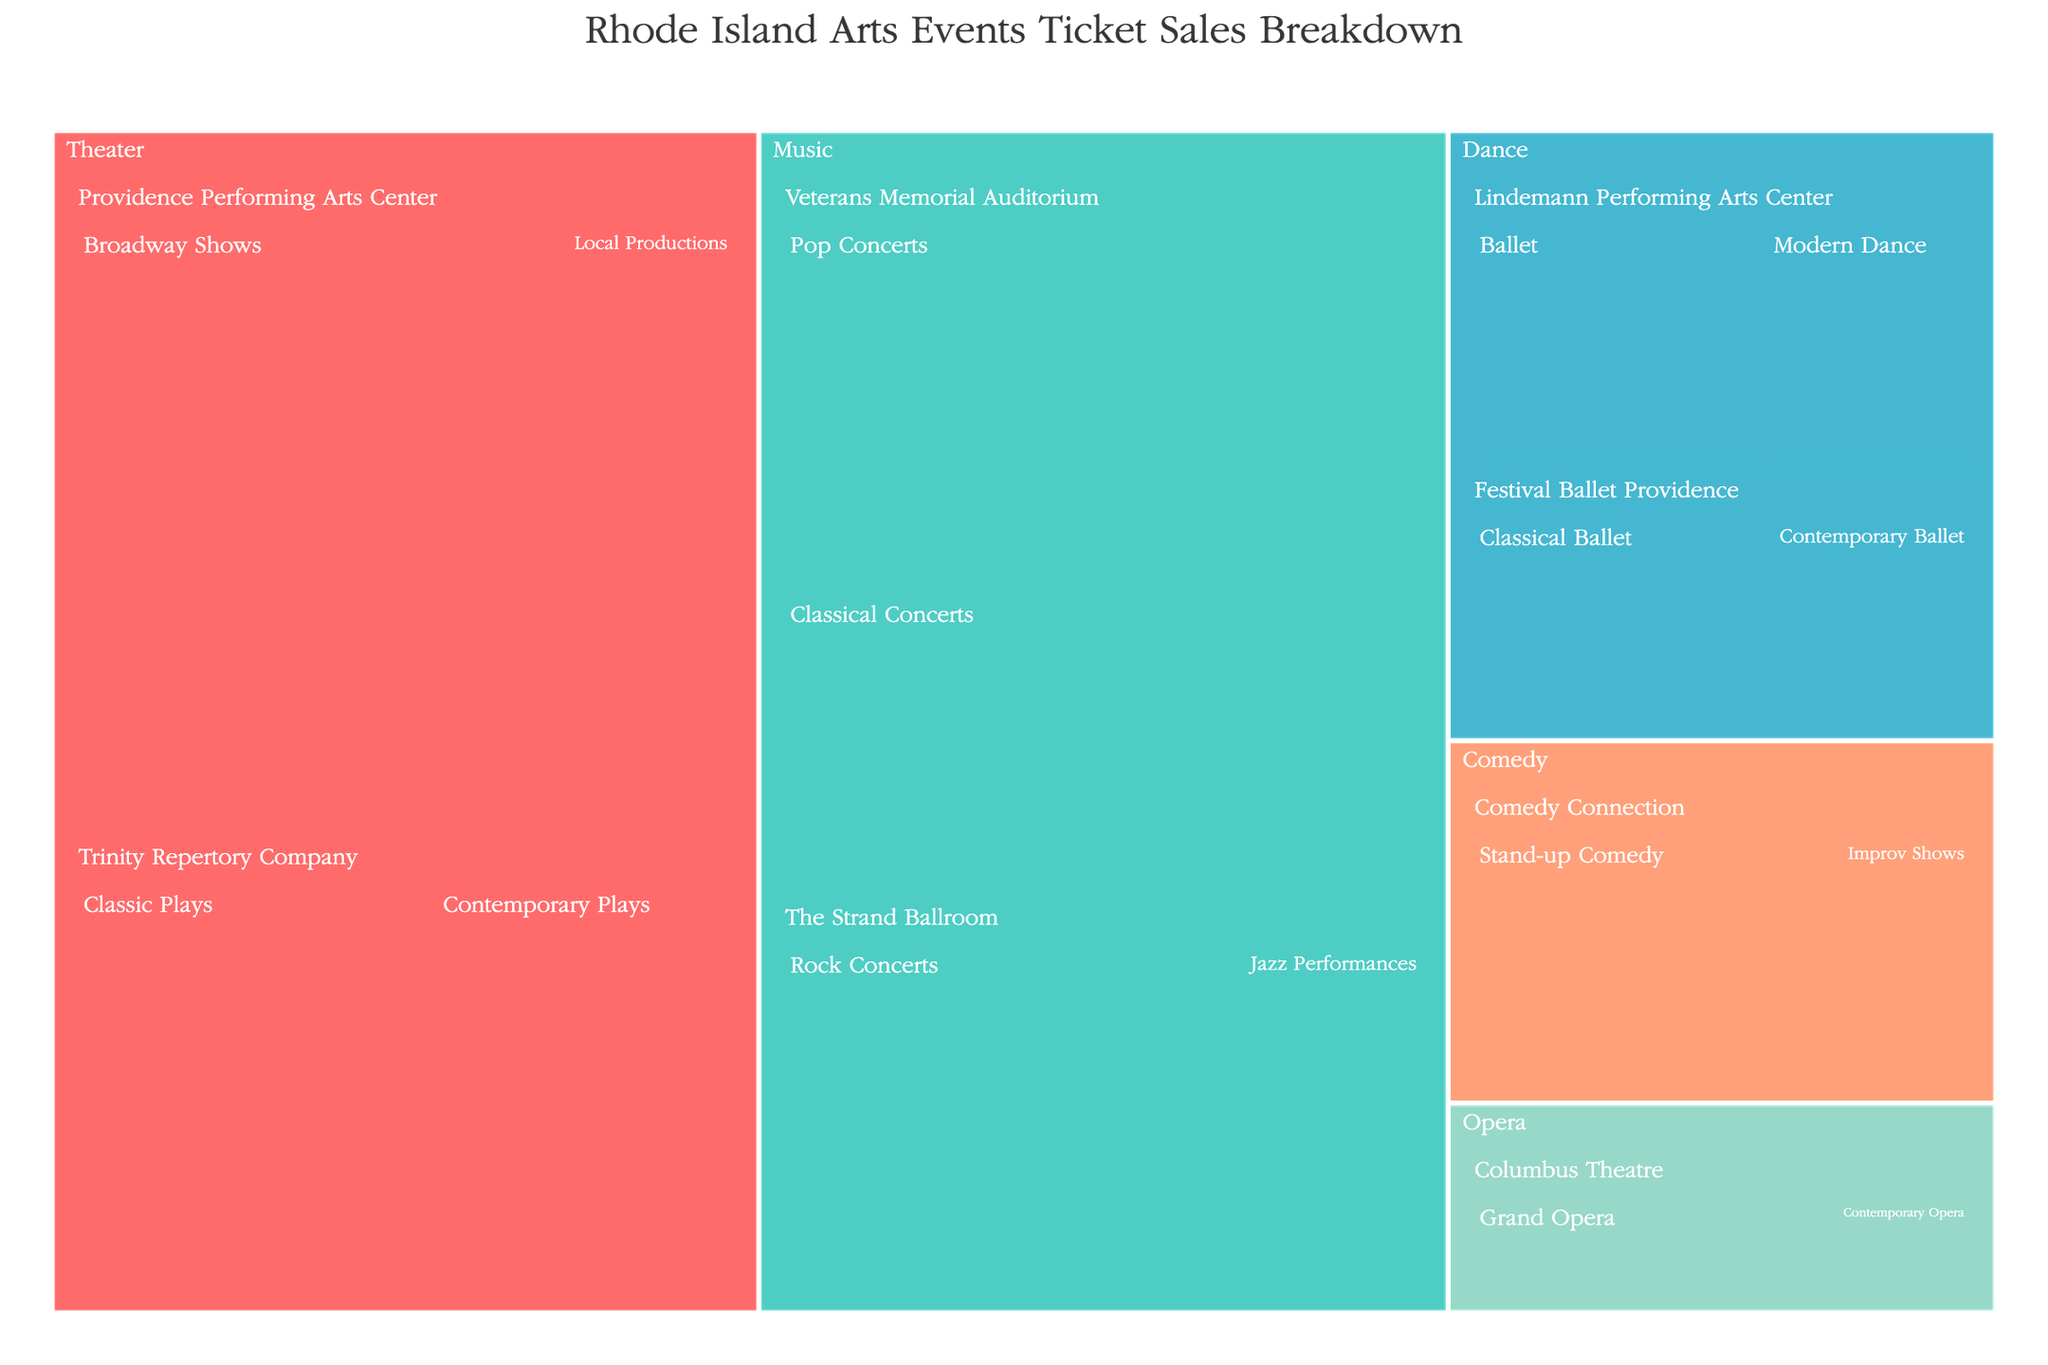How many major categories of arts events are shown in the treemap? Count the distinct major categories listed in the treemap. In this case, they are Theater, Music, Dance, Comedy, and Opera.
Answer: 5 What is the title of the figure? Read the main title at the top of the treemap.
Answer: Rhode Island Arts Events Ticket Sales Breakdown Which venue type has the highest ticket sales for pop concerts? Identify the Pop Concerts section in Music and see which venue type it is associated with.
Answer: Veterans Memorial Auditorium What's the total ticket sales for Theater category? Sum ticket sales from all performance types within Theater. 35000 + 12000 + 18000 + 15000 = 80000
Answer: 80000 Which performance type has the lowest ticket sales in the Music category? Look for the smallest section within the Music category and check its label.
Answer: Jazz Performances By how much do the ticket sales for Classical Ballet exceed those for Contemporary Ballet at Festival Ballet Providence? Subtract the ticket sales of Contemporary Ballet from Classical Ballet. 9000 - 6000 = 3000
Answer: 3000 How do ticket sales for Contemporary Plays at Trinity Repertory Company compare to Local Productions at Providence Performing Arts Center? Compare the values of Contemporary Plays (15000) and Local Productions (12000). Contemporary Plays has higher sales.
Answer: Contemporary Plays higher What's the combined ticket sales for all dance events at Lindemann Performing Arts Center? Sum the ticket sales for Ballet (10000) and Modern Dance (7000). 10000 + 7000 = 17000
Answer: 17000 Can you list all performance types offered at the Comedy Connection? Identify and list all performance types under the Comedy category at the Comedy Connection.
Answer: Stand-up Comedy, Improv Shows 